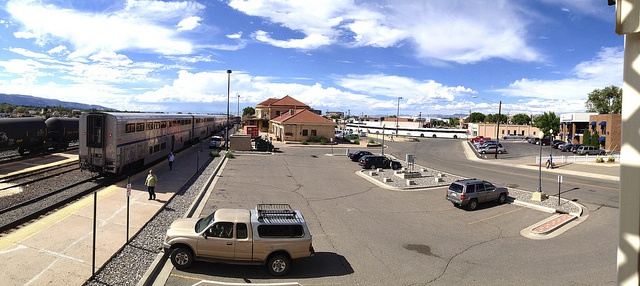Describe the objects in this image and their specific colors. I can see car in lightblue, black, gray, maroon, and ivory tones, truck in lightblue, black, gray, maroon, and ivory tones, train in lightblue, black, gray, and darkgray tones, train in lightblue, black, gray, and maroon tones, and car in lightblue, black, gray, and darkgray tones in this image. 